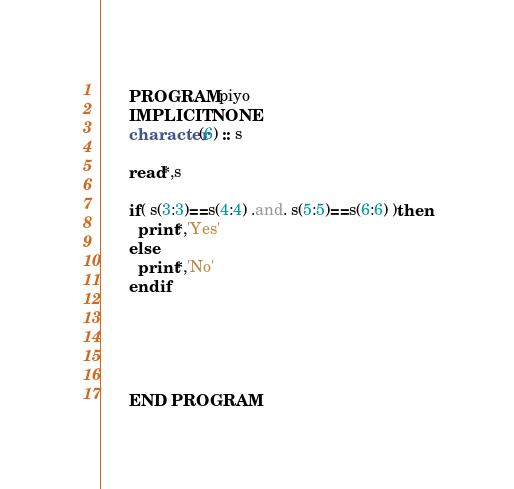<code> <loc_0><loc_0><loc_500><loc_500><_FORTRAN_>      PROGRAM piyo
      IMPLICIT NONE
      character(6) :: s
      
      read*,s
      
      if( s(3:3)==s(4:4) .and. s(5:5)==s(6:6) )then
        print*,'Yes'
      else
        print*,'No'
      end if
      
      
      
      
      
      END PROGRAM</code> 